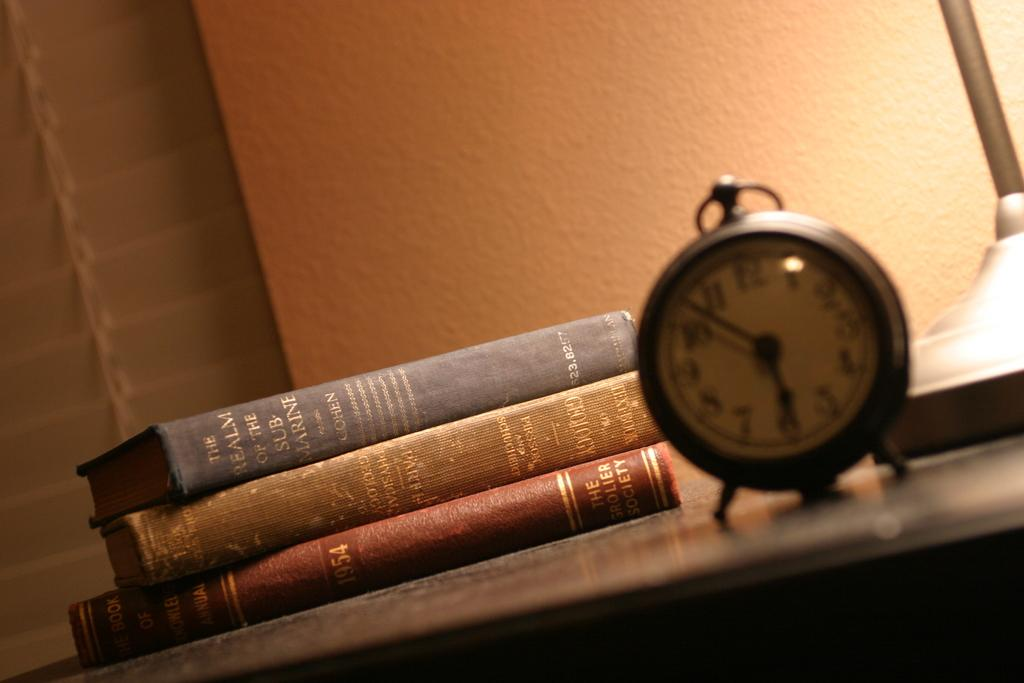Provide a one-sentence caption for the provided image. Three books on a desk, one of which being about submarines, along with an out of focus clock in front of them. 